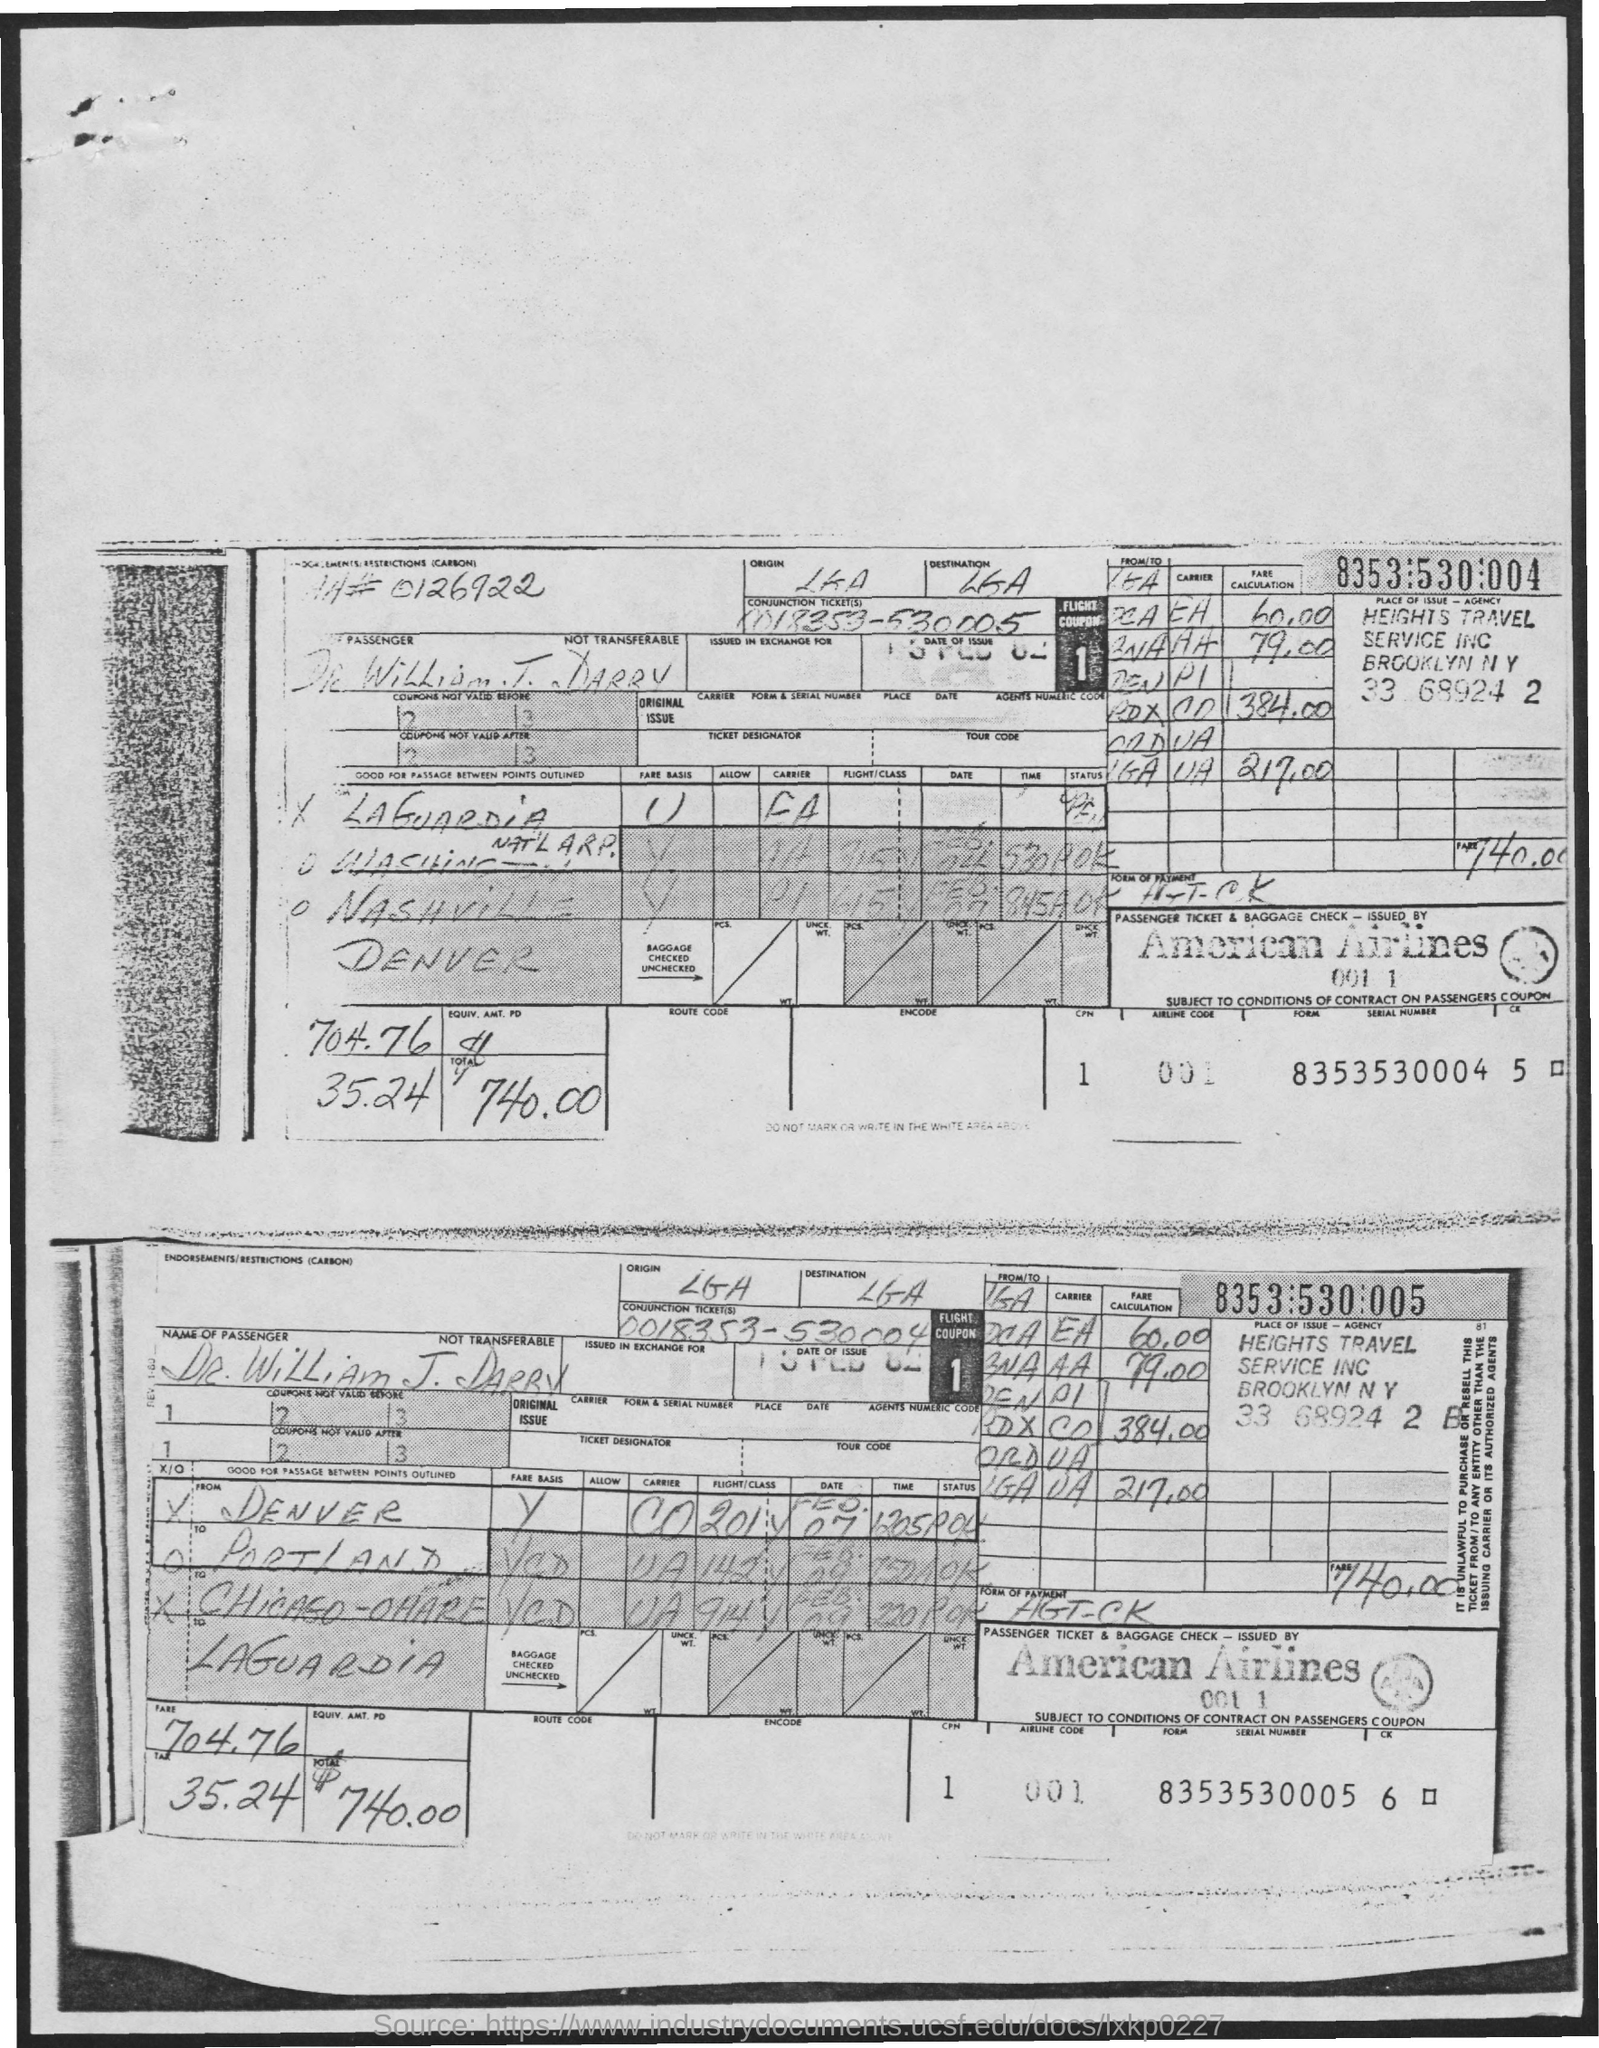What is the name of the Airline?
Provide a succinct answer. American airlines. What is the Airline Code?
Keep it short and to the point. 001. What is the tax amount?
Provide a succinct answer. 35.24. What is the fare?
Offer a very short reply. 704.76. What is the Total?
Your answer should be very brief. $740.00. 